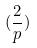<formula> <loc_0><loc_0><loc_500><loc_500>( \frac { 2 } { p } )</formula> 